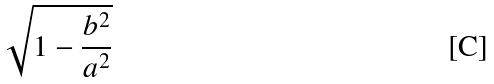<formula> <loc_0><loc_0><loc_500><loc_500>\sqrt { 1 - \frac { b ^ { 2 } } { a ^ { 2 } } }</formula> 